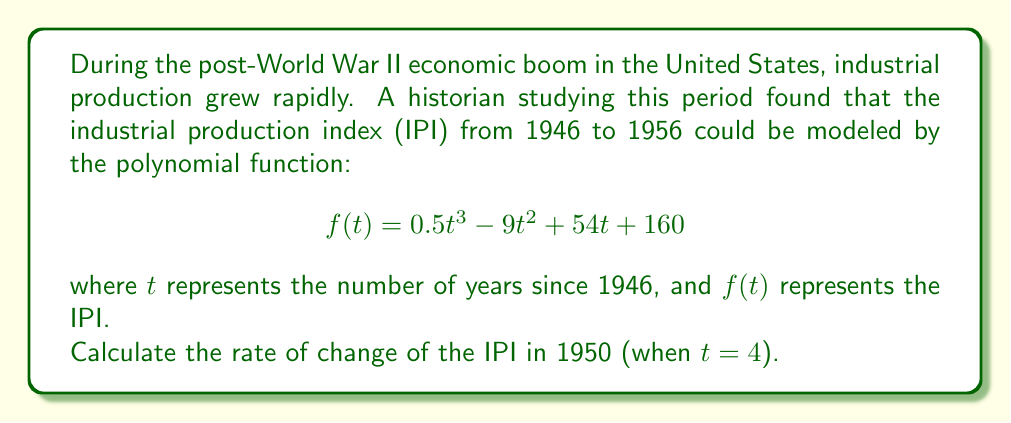Solve this math problem. To find the rate of change of the IPI in 1950, we need to follow these steps:

1) The rate of change is given by the first derivative of the function. Let's call this $f'(t)$.

2) To find $f'(t)$, we differentiate $f(t)$ with respect to $t$:
   $$f'(t) = \frac{d}{dt}(0.5t^3 - 9t^2 + 54t + 160)$$

3) Using the power rule of differentiation:
   $$f'(t) = 1.5t^2 - 18t + 54$$

4) Now, we need to evaluate $f'(t)$ at $t = 4$ (which corresponds to 1950):
   $$f'(4) = 1.5(4)^2 - 18(4) + 54$$

5) Let's calculate this step by step:
   $$f'(4) = 1.5(16) - 72 + 54$$
   $$f'(4) = 24 - 72 + 54$$
   $$f'(4) = 6$$

Therefore, the rate of change of the IPI in 1950 was 6 index points per year.
Answer: 6 index points per year 